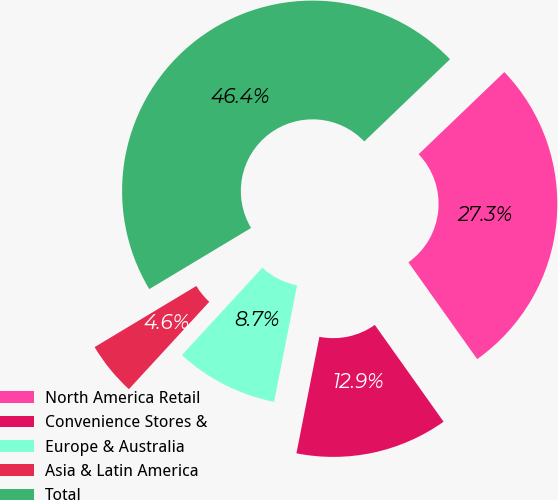Convert chart to OTSL. <chart><loc_0><loc_0><loc_500><loc_500><pie_chart><fcel>North America Retail<fcel>Convenience Stores &<fcel>Europe & Australia<fcel>Asia & Latin America<fcel>Total<nl><fcel>27.33%<fcel>12.93%<fcel>8.74%<fcel>4.55%<fcel>46.44%<nl></chart> 